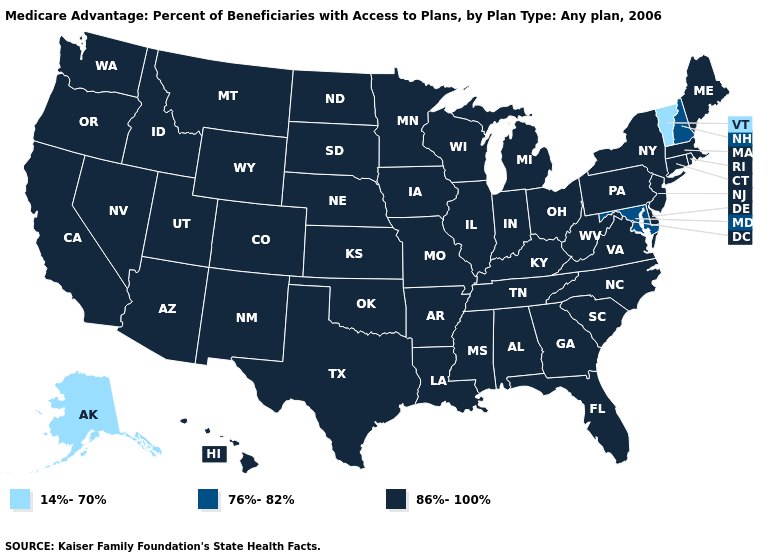What is the value of Mississippi?
Answer briefly. 86%-100%. Name the states that have a value in the range 86%-100%?
Quick response, please. Alabama, Arkansas, Arizona, California, Colorado, Connecticut, Delaware, Florida, Georgia, Hawaii, Iowa, Idaho, Illinois, Indiana, Kansas, Kentucky, Louisiana, Massachusetts, Maine, Michigan, Minnesota, Missouri, Mississippi, Montana, North Carolina, North Dakota, Nebraska, New Jersey, New Mexico, Nevada, New York, Ohio, Oklahoma, Oregon, Pennsylvania, Rhode Island, South Carolina, South Dakota, Tennessee, Texas, Utah, Virginia, Washington, Wisconsin, West Virginia, Wyoming. Which states hav the highest value in the South?
Concise answer only. Alabama, Arkansas, Delaware, Florida, Georgia, Kentucky, Louisiana, Mississippi, North Carolina, Oklahoma, South Carolina, Tennessee, Texas, Virginia, West Virginia. What is the lowest value in the South?
Concise answer only. 76%-82%. What is the highest value in the USA?
Short answer required. 86%-100%. Name the states that have a value in the range 14%-70%?
Quick response, please. Alaska, Vermont. Name the states that have a value in the range 14%-70%?
Short answer required. Alaska, Vermont. What is the lowest value in the USA?
Quick response, please. 14%-70%. Name the states that have a value in the range 86%-100%?
Write a very short answer. Alabama, Arkansas, Arizona, California, Colorado, Connecticut, Delaware, Florida, Georgia, Hawaii, Iowa, Idaho, Illinois, Indiana, Kansas, Kentucky, Louisiana, Massachusetts, Maine, Michigan, Minnesota, Missouri, Mississippi, Montana, North Carolina, North Dakota, Nebraska, New Jersey, New Mexico, Nevada, New York, Ohio, Oklahoma, Oregon, Pennsylvania, Rhode Island, South Carolina, South Dakota, Tennessee, Texas, Utah, Virginia, Washington, Wisconsin, West Virginia, Wyoming. Name the states that have a value in the range 86%-100%?
Keep it brief. Alabama, Arkansas, Arizona, California, Colorado, Connecticut, Delaware, Florida, Georgia, Hawaii, Iowa, Idaho, Illinois, Indiana, Kansas, Kentucky, Louisiana, Massachusetts, Maine, Michigan, Minnesota, Missouri, Mississippi, Montana, North Carolina, North Dakota, Nebraska, New Jersey, New Mexico, Nevada, New York, Ohio, Oklahoma, Oregon, Pennsylvania, Rhode Island, South Carolina, South Dakota, Tennessee, Texas, Utah, Virginia, Washington, Wisconsin, West Virginia, Wyoming. What is the lowest value in the South?
Give a very brief answer. 76%-82%. Name the states that have a value in the range 76%-82%?
Keep it brief. Maryland, New Hampshire. Does Indiana have the highest value in the USA?
Write a very short answer. Yes. What is the value of Oklahoma?
Be succinct. 86%-100%. 